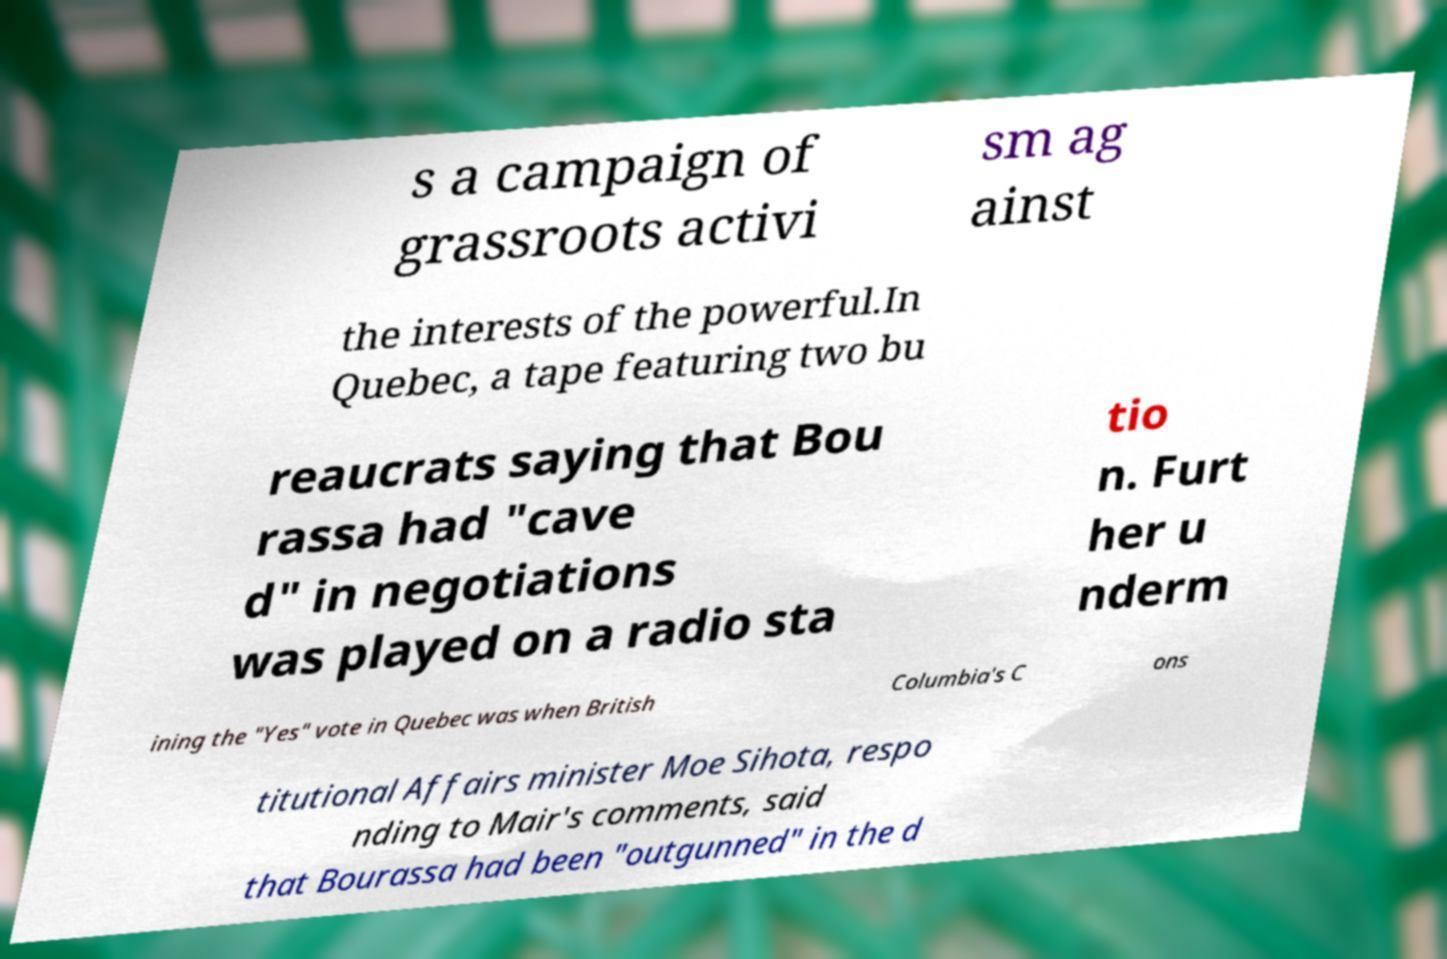There's text embedded in this image that I need extracted. Can you transcribe it verbatim? s a campaign of grassroots activi sm ag ainst the interests of the powerful.In Quebec, a tape featuring two bu reaucrats saying that Bou rassa had "cave d" in negotiations was played on a radio sta tio n. Furt her u nderm ining the "Yes" vote in Quebec was when British Columbia's C ons titutional Affairs minister Moe Sihota, respo nding to Mair's comments, said that Bourassa had been "outgunned" in the d 